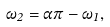<formula> <loc_0><loc_0><loc_500><loc_500>\omega _ { 2 } = \alpha \pi - \omega _ { 1 } ,</formula> 